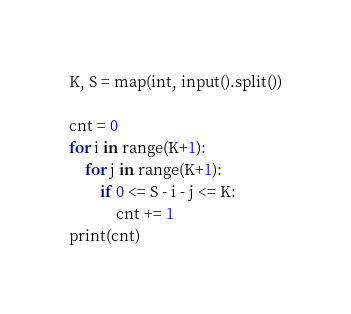<code> <loc_0><loc_0><loc_500><loc_500><_Python_>K, S = map(int, input().split())

cnt = 0
for i in range(K+1):
    for j in range(K+1):
        if 0 <= S - i - j <= K:
            cnt += 1
print(cnt)
</code> 